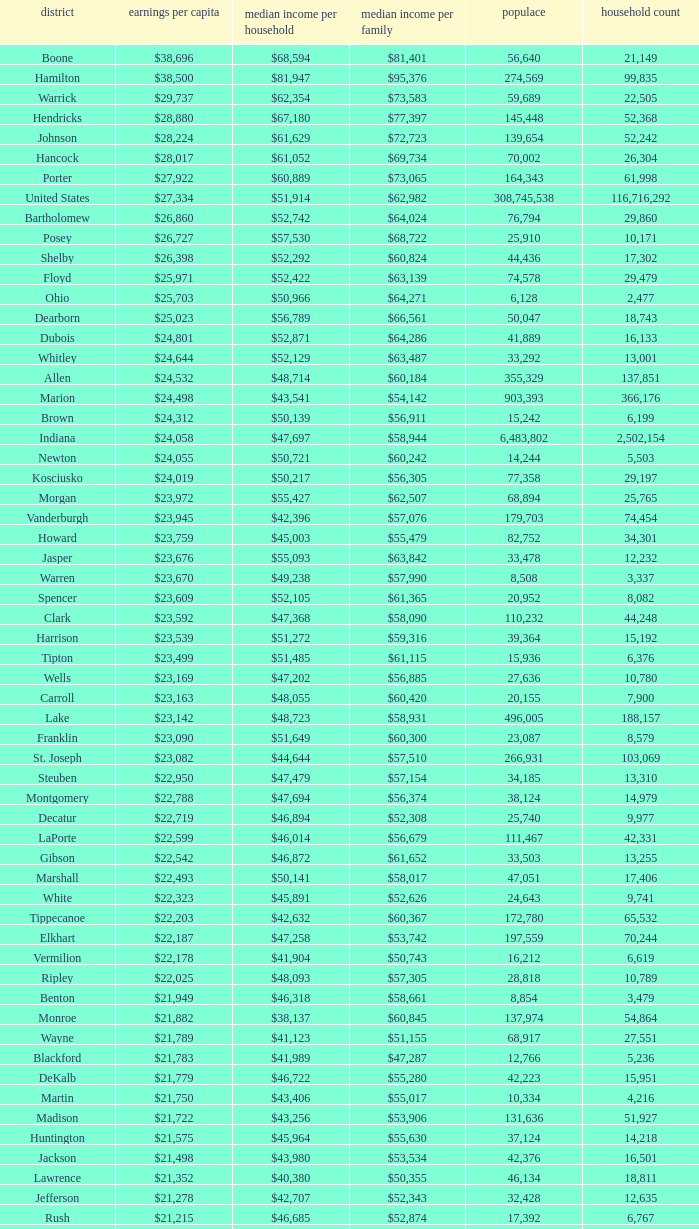Would you be able to parse every entry in this table? {'header': ['district', 'earnings per capita', 'median income per household', 'median income per family', 'populace', 'household count'], 'rows': [['Boone', '$38,696', '$68,594', '$81,401', '56,640', '21,149'], ['Hamilton', '$38,500', '$81,947', '$95,376', '274,569', '99,835'], ['Warrick', '$29,737', '$62,354', '$73,583', '59,689', '22,505'], ['Hendricks', '$28,880', '$67,180', '$77,397', '145,448', '52,368'], ['Johnson', '$28,224', '$61,629', '$72,723', '139,654', '52,242'], ['Hancock', '$28,017', '$61,052', '$69,734', '70,002', '26,304'], ['Porter', '$27,922', '$60,889', '$73,065', '164,343', '61,998'], ['United States', '$27,334', '$51,914', '$62,982', '308,745,538', '116,716,292'], ['Bartholomew', '$26,860', '$52,742', '$64,024', '76,794', '29,860'], ['Posey', '$26,727', '$57,530', '$68,722', '25,910', '10,171'], ['Shelby', '$26,398', '$52,292', '$60,824', '44,436', '17,302'], ['Floyd', '$25,971', '$52,422', '$63,139', '74,578', '29,479'], ['Ohio', '$25,703', '$50,966', '$64,271', '6,128', '2,477'], ['Dearborn', '$25,023', '$56,789', '$66,561', '50,047', '18,743'], ['Dubois', '$24,801', '$52,871', '$64,286', '41,889', '16,133'], ['Whitley', '$24,644', '$52,129', '$63,487', '33,292', '13,001'], ['Allen', '$24,532', '$48,714', '$60,184', '355,329', '137,851'], ['Marion', '$24,498', '$43,541', '$54,142', '903,393', '366,176'], ['Brown', '$24,312', '$50,139', '$56,911', '15,242', '6,199'], ['Indiana', '$24,058', '$47,697', '$58,944', '6,483,802', '2,502,154'], ['Newton', '$24,055', '$50,721', '$60,242', '14,244', '5,503'], ['Kosciusko', '$24,019', '$50,217', '$56,305', '77,358', '29,197'], ['Morgan', '$23,972', '$55,427', '$62,507', '68,894', '25,765'], ['Vanderburgh', '$23,945', '$42,396', '$57,076', '179,703', '74,454'], ['Howard', '$23,759', '$45,003', '$55,479', '82,752', '34,301'], ['Jasper', '$23,676', '$55,093', '$63,842', '33,478', '12,232'], ['Warren', '$23,670', '$49,238', '$57,990', '8,508', '3,337'], ['Spencer', '$23,609', '$52,105', '$61,365', '20,952', '8,082'], ['Clark', '$23,592', '$47,368', '$58,090', '110,232', '44,248'], ['Harrison', '$23,539', '$51,272', '$59,316', '39,364', '15,192'], ['Tipton', '$23,499', '$51,485', '$61,115', '15,936', '6,376'], ['Wells', '$23,169', '$47,202', '$56,885', '27,636', '10,780'], ['Carroll', '$23,163', '$48,055', '$60,420', '20,155', '7,900'], ['Lake', '$23,142', '$48,723', '$58,931', '496,005', '188,157'], ['Franklin', '$23,090', '$51,649', '$60,300', '23,087', '8,579'], ['St. Joseph', '$23,082', '$44,644', '$57,510', '266,931', '103,069'], ['Steuben', '$22,950', '$47,479', '$57,154', '34,185', '13,310'], ['Montgomery', '$22,788', '$47,694', '$56,374', '38,124', '14,979'], ['Decatur', '$22,719', '$46,894', '$52,308', '25,740', '9,977'], ['LaPorte', '$22,599', '$46,014', '$56,679', '111,467', '42,331'], ['Gibson', '$22,542', '$46,872', '$61,652', '33,503', '13,255'], ['Marshall', '$22,493', '$50,141', '$58,017', '47,051', '17,406'], ['White', '$22,323', '$45,891', '$52,626', '24,643', '9,741'], ['Tippecanoe', '$22,203', '$42,632', '$60,367', '172,780', '65,532'], ['Elkhart', '$22,187', '$47,258', '$53,742', '197,559', '70,244'], ['Vermilion', '$22,178', '$41,904', '$50,743', '16,212', '6,619'], ['Ripley', '$22,025', '$48,093', '$57,305', '28,818', '10,789'], ['Benton', '$21,949', '$46,318', '$58,661', '8,854', '3,479'], ['Monroe', '$21,882', '$38,137', '$60,845', '137,974', '54,864'], ['Wayne', '$21,789', '$41,123', '$51,155', '68,917', '27,551'], ['Blackford', '$21,783', '$41,989', '$47,287', '12,766', '5,236'], ['DeKalb', '$21,779', '$46,722', '$55,280', '42,223', '15,951'], ['Martin', '$21,750', '$43,406', '$55,017', '10,334', '4,216'], ['Madison', '$21,722', '$43,256', '$53,906', '131,636', '51,927'], ['Huntington', '$21,575', '$45,964', '$55,630', '37,124', '14,218'], ['Jackson', '$21,498', '$43,980', '$53,534', '42,376', '16,501'], ['Lawrence', '$21,352', '$40,380', '$50,355', '46,134', '18,811'], ['Jefferson', '$21,278', '$42,707', '$52,343', '32,428', '12,635'], ['Rush', '$21,215', '$46,685', '$52,874', '17,392', '6,767'], ['Switzerland', '$21,214', '$44,503', '$51,769', '10,613', '4,034'], ['Clinton', '$21,131', '$48,416', '$57,445', '33,224', '12,105'], ['Fulton', '$21,119', '$40,372', '$47,972', '20,836', '8,237'], ['Fountain', '$20,949', '$42,817', '$51,696', '17,240', '6,935'], ['Perry', '$20,806', '$45,108', '$55,497', '19,338', '7,476'], ['Greene', '$20,676', '$41,103', '$50,740', '33,165', '13,487'], ['Owen', '$20,581', '$44,285', '$52,343', '21,575', '8,486'], ['Clay', '$20,569', '$44,666', '$52,907', '26,890', '10,447'], ['Cass', '$20,562', '$42,587', '$49,873', '38,966', '14,858'], ['Pulaski', '$20,491', '$44,016', '$50,903', '13,402', '5,282'], ['Wabash', '$20,475', '$43,157', '$52,758', '32,888', '12,777'], ['Putnam', '$20,441', '$48,992', '$59,354', '37,963', '12,917'], ['Delaware', '$20,405', '$38,066', '$51,394', '117,671', '46,516'], ['Vigo', '$20,398', '$38,508', '$50,413', '107,848', '41,361'], ['Knox', '$20,381', '$39,523', '$51,534', '38,440', '15,249'], ['Daviess', '$20,254', '$44,592', '$53,769', '31,648', '11,329'], ['Sullivan', '$20,093', '$44,184', '$52,558', '21,475', '7,823'], ['Pike', '$20,005', '$41,222', '$49,423', '12,845', '5,186'], ['Henry', '$19,879', '$41,087', '$52,701', '49,462', '19,077'], ['Grant', '$19,792', '$38,985', '$49,860', '70,061', '27,245'], ['Noble', '$19,783', '$45,818', '$53,959', '47,536', '17,355'], ['Randolph', '$19,552', '$40,990', '$45,543', '26,171', '10,451'], ['Parke', '$19,494', '$40,512', '$51,581', '17,339', '6,222'], ['Scott', '$19,414', '$39,588', '$46,775', '24,181', '9,397'], ['Washington', '$19,278', '$39,722', '$45,500', '28,262', '10,850'], ['Union', '$19,243', '$43,257', '$49,815', '7,516', '2,938'], ['Orange', '$19,119', '$37,120', '$45,874', '19,840', '7,872'], ['Adams', '$19,089', '$43,317', '$53,106', '34,387', '12,011'], ['Jay', '$18,946', '$39,886', '$47,926', '21,253', '8,133'], ['Fayette', '$18,928', '$37,038', '$46,601', '24,277', '9,719'], ['Miami', '$18,854', '$39,485', '$49,282', '36,903', '13,456'], ['Jennings', '$18,636', '$43,755', '$48,470', '28,525', '10,680'], ['Crawford', '$18,598', '$37,988', '$46,073', '10,713', '4,303'], ['LaGrange', '$18,388', '$47,792', '$53,793', '37,128', '11,598'], ['Starke', '$17,991', '$37,480', '$44,044', '23,363', '9,038']]} What County has a Median household income of $46,872? Gibson. 